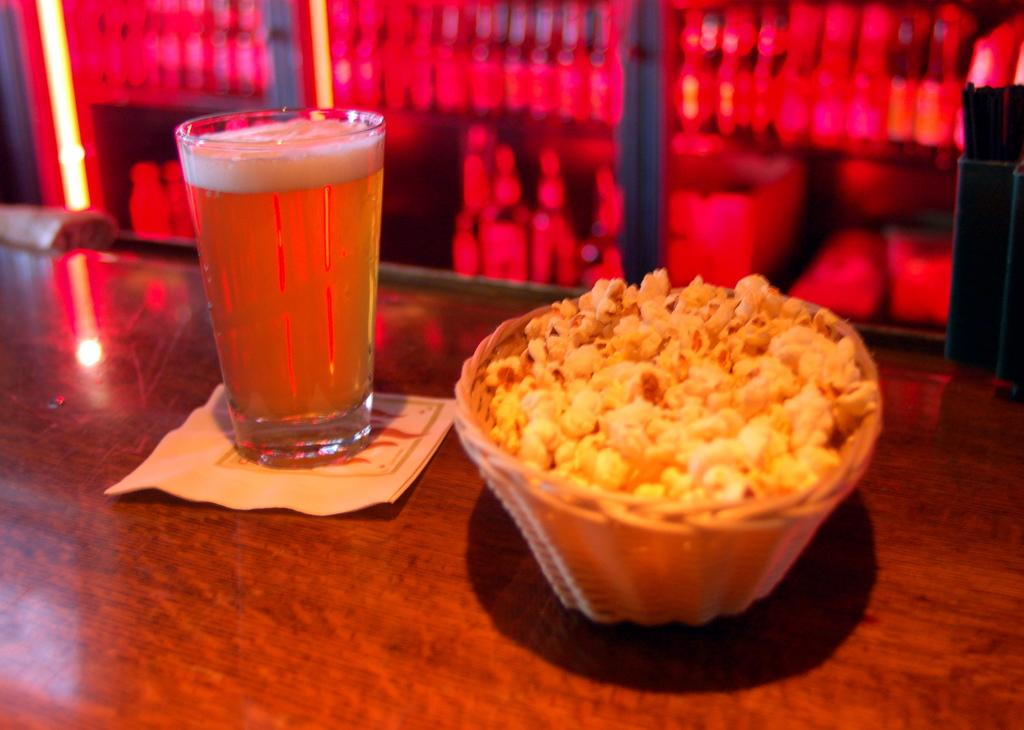What is in the glass that is visible in the image? There is a drink in the glass in the image. What other items can be seen in the image besides the glass? There is paper, popcorn in a bowl, other objects on a table, and bottles in the image. What color is the background of the image? The background of the image is red. What type of cart is being used to serve the drinks in the image? There is no cart present in the image; it only shows a glass with a drink and other items on a table. 